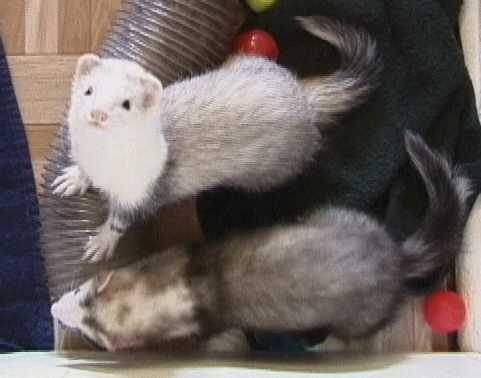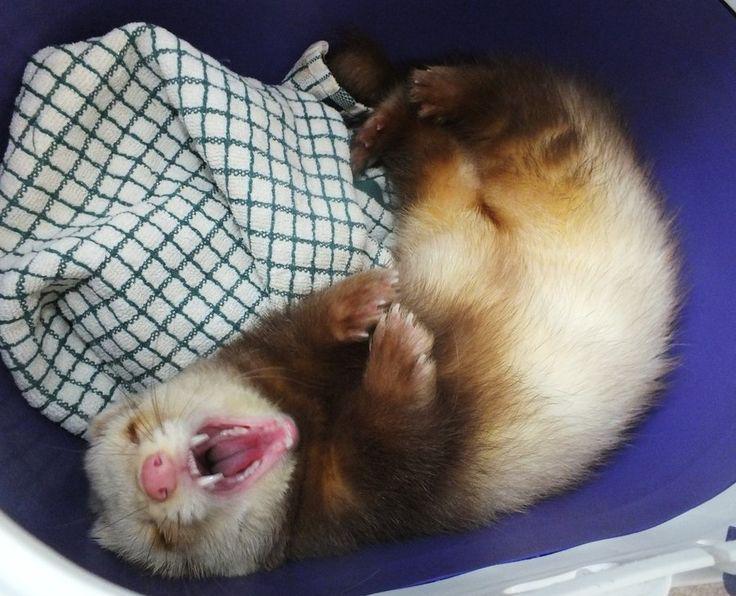The first image is the image on the left, the second image is the image on the right. Considering the images on both sides, is "In one of the images, exactly one ferret is sleeping with both eyes and mouth closed." valid? Answer yes or no. No. The first image is the image on the left, the second image is the image on the right. For the images displayed, is the sentence "Three ferrets are sleeping." factually correct? Answer yes or no. No. 